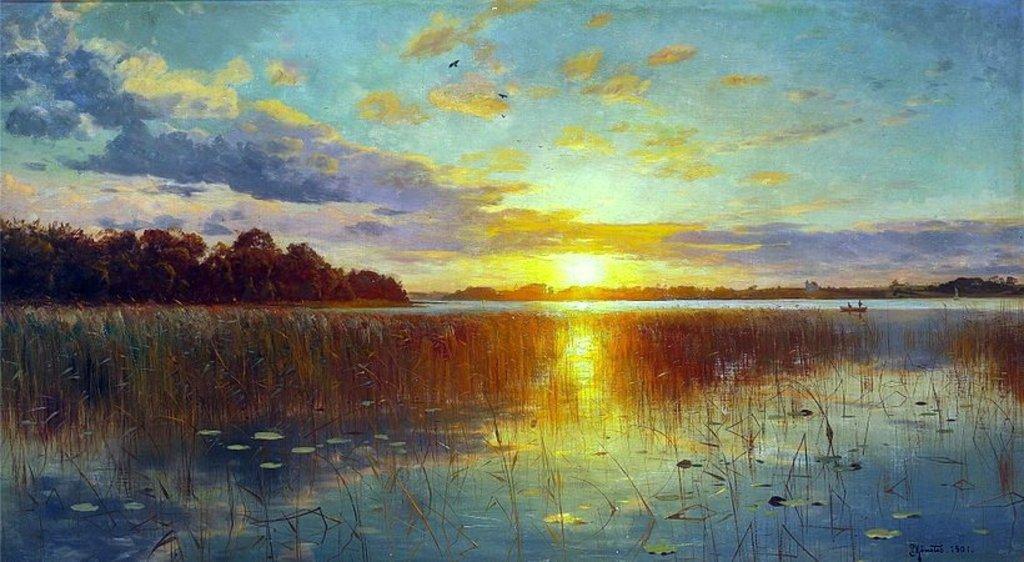How would you summarize this image in a sentence or two? It is looking like a painting, we can see there are plants in the water and a boat on the water. Behind the boat there are trees and a sky and it is written something on the image. 